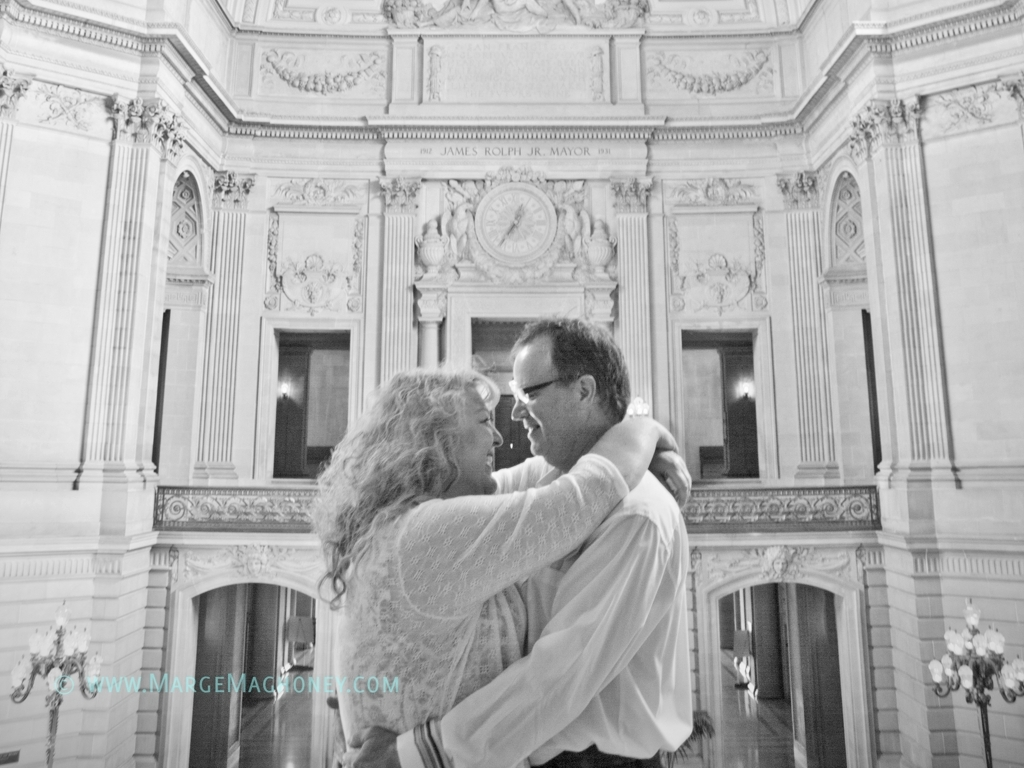What emotions do you perceive from the couple in this image? The couple in the image exudes a sense of gentle affection and contentment. Their close embrace and the way they gaze into each other's eyes suggest a deep connection and mutual comfort, emphasizing a moment of serene intimacy. 